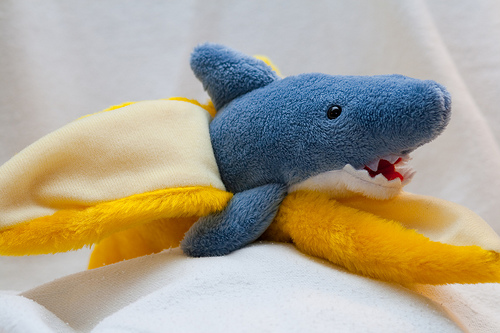<image>
Is the shark in front of the banana? No. The shark is not in front of the banana. The spatial positioning shows a different relationship between these objects. 